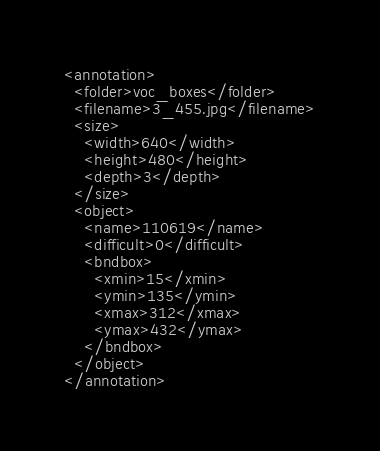<code> <loc_0><loc_0><loc_500><loc_500><_XML_><annotation>
  <folder>voc_boxes</folder>
  <filename>3_455.jpg</filename>
  <size>
    <width>640</width>
    <height>480</height>
    <depth>3</depth>
  </size>
  <object>
    <name>110619</name>
    <difficult>0</difficult>
    <bndbox>
      <xmin>15</xmin>
      <ymin>135</ymin>
      <xmax>312</xmax>
      <ymax>432</ymax>
    </bndbox>
  </object>
</annotation></code> 